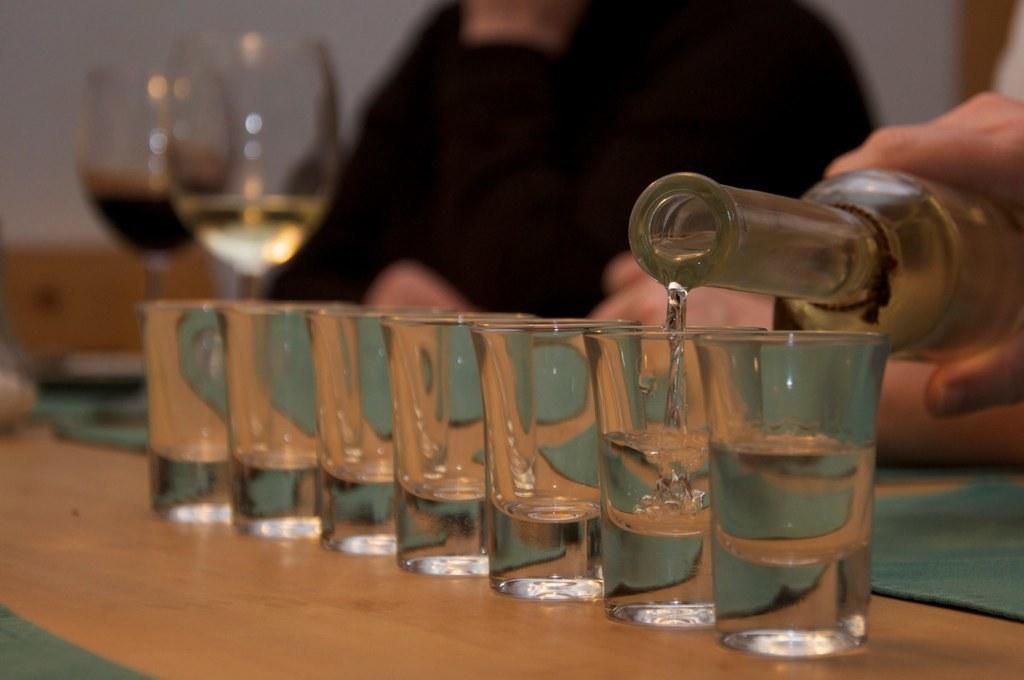Who is present in the image? There is a person in the image. What is the person holding in the image? The person is holding a bottle in the image. What is the person doing with the bottle? The person is pouring juice from the bottle. Where are the glasses that the juice is being poured into? The glasses are on a table. What type of flowers are being used as a garnish for the juice in the image? There are no flowers present in the image; the person is pouring juice into glasses on a table. 